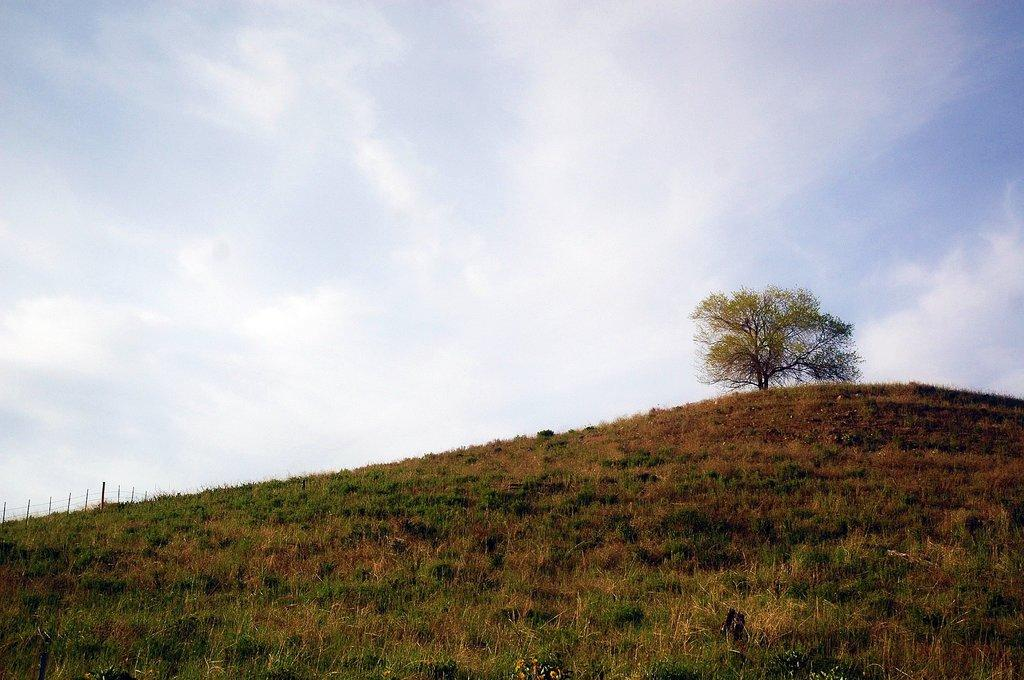What type of vegetation is present in the image? There is grass in the image. What geographical feature can be seen in the image? There is a tree on a mountain in the image. What is visible in the background of the image? The sky is visible in the background of the image. How many doors are visible in the image? There are no doors present in the image. What time of day is depicted in the image? The time of day cannot be determined from the image, as there are no specific indicators of time. 